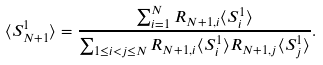<formula> <loc_0><loc_0><loc_500><loc_500>\langle S _ { N + 1 } ^ { 1 } \rangle = \frac { \sum _ { i = 1 } ^ { N } R _ { N + 1 , i } \langle S _ { i } ^ { 1 } \rangle } { \sum _ { 1 \leq i < j \leq N } R _ { N + 1 , i } \langle S _ { i } ^ { 1 } \rangle R _ { N + 1 , j } \langle S _ { j } ^ { 1 } \rangle } .</formula> 